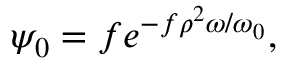Convert formula to latex. <formula><loc_0><loc_0><loc_500><loc_500>\psi _ { 0 } = f e ^ { - f \rho ^ { 2 } \omega / \omega _ { 0 } } ,</formula> 